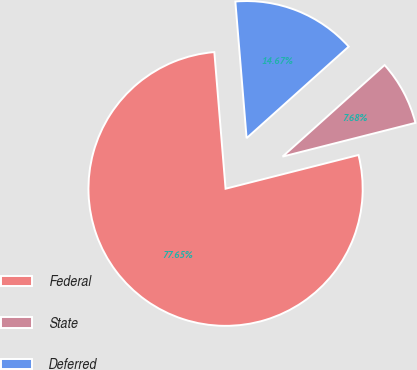<chart> <loc_0><loc_0><loc_500><loc_500><pie_chart><fcel>Federal<fcel>State<fcel>Deferred<nl><fcel>77.65%<fcel>7.68%<fcel>14.67%<nl></chart> 